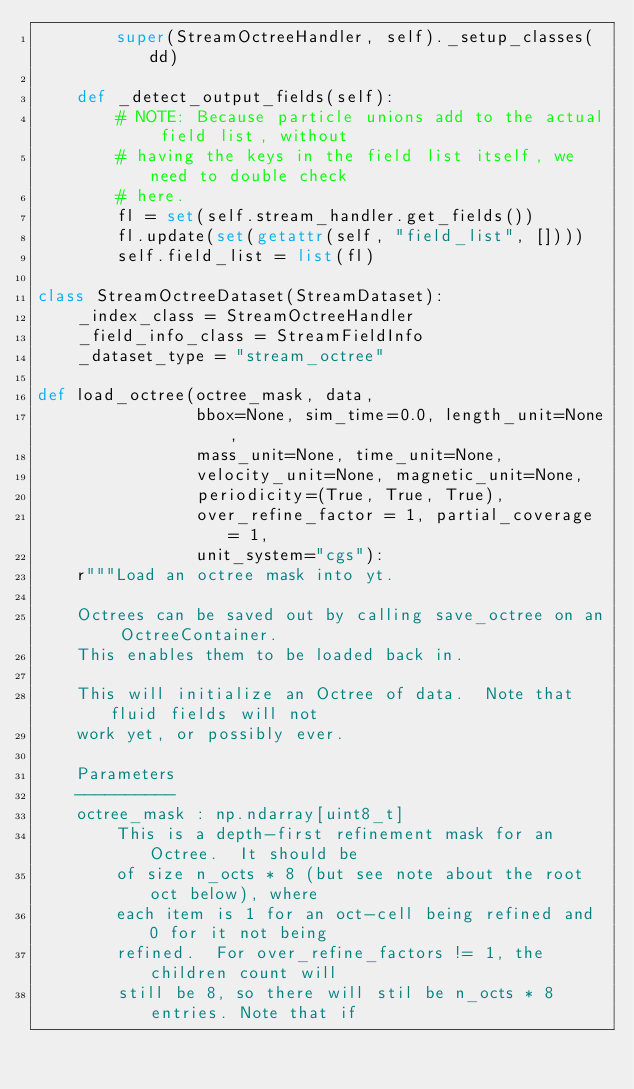Convert code to text. <code><loc_0><loc_0><loc_500><loc_500><_Python_>        super(StreamOctreeHandler, self)._setup_classes(dd)

    def _detect_output_fields(self):
        # NOTE: Because particle unions add to the actual field list, without
        # having the keys in the field list itself, we need to double check
        # here.
        fl = set(self.stream_handler.get_fields())
        fl.update(set(getattr(self, "field_list", [])))
        self.field_list = list(fl)

class StreamOctreeDataset(StreamDataset):
    _index_class = StreamOctreeHandler
    _field_info_class = StreamFieldInfo
    _dataset_type = "stream_octree"

def load_octree(octree_mask, data,
                bbox=None, sim_time=0.0, length_unit=None,
                mass_unit=None, time_unit=None,
                velocity_unit=None, magnetic_unit=None,
                periodicity=(True, True, True),
                over_refine_factor = 1, partial_coverage = 1,
                unit_system="cgs"):
    r"""Load an octree mask into yt.

    Octrees can be saved out by calling save_octree on an OctreeContainer.
    This enables them to be loaded back in.

    This will initialize an Octree of data.  Note that fluid fields will not
    work yet, or possibly ever.

    Parameters
    ----------
    octree_mask : np.ndarray[uint8_t]
        This is a depth-first refinement mask for an Octree.  It should be 
        of size n_octs * 8 (but see note about the root oct below), where 
        each item is 1 for an oct-cell being refined and 0 for it not being
        refined.  For over_refine_factors != 1, the children count will 
        still be 8, so there will stil be n_octs * 8 entries. Note that if </code> 